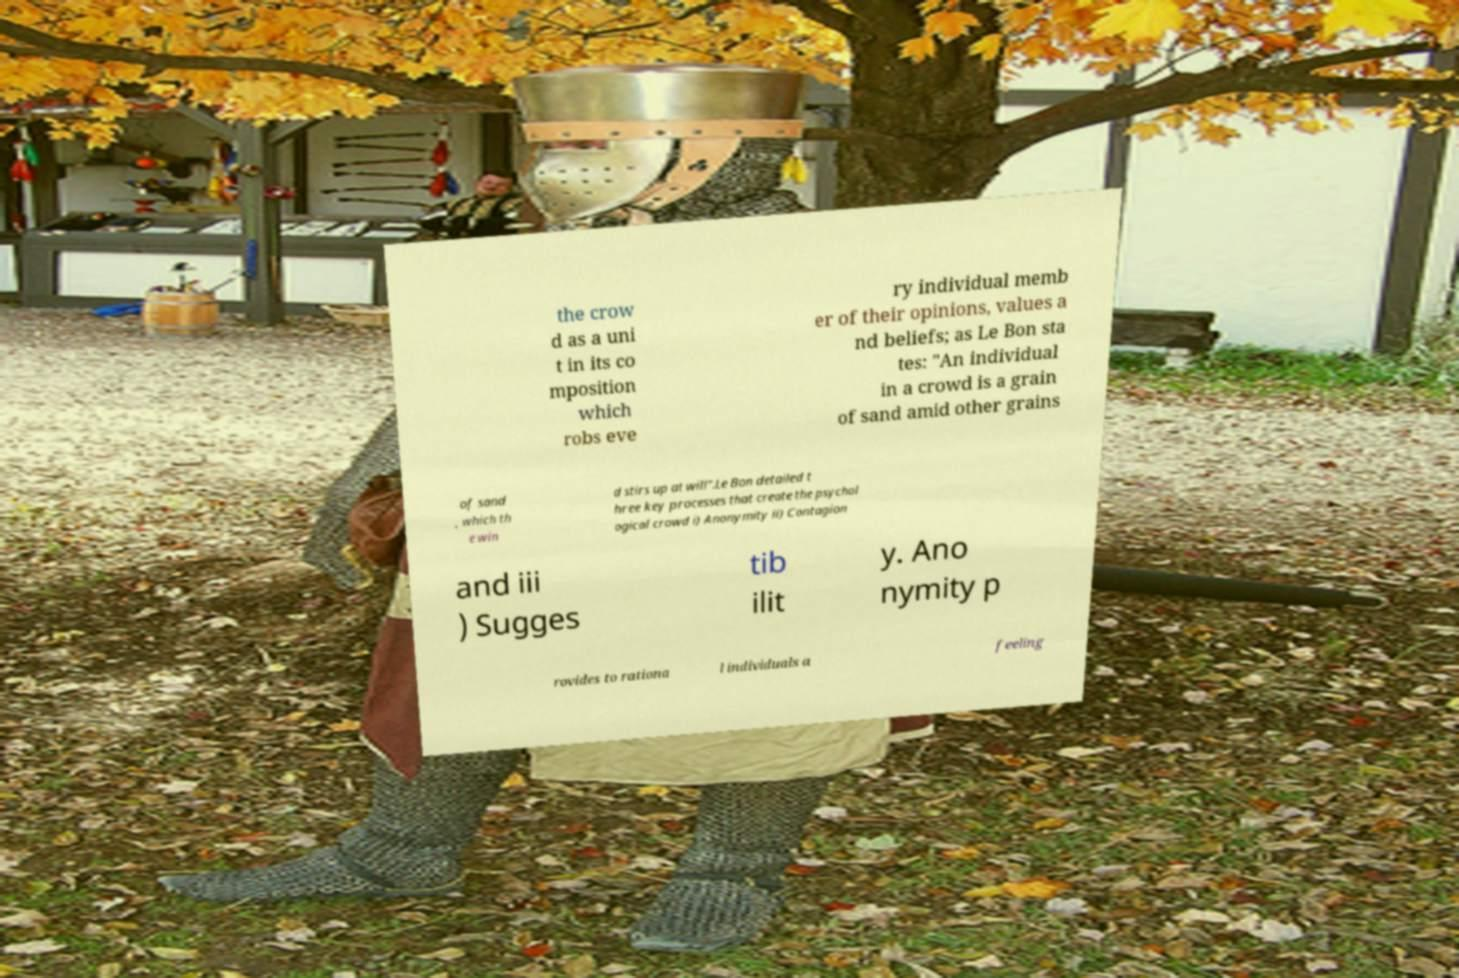Could you assist in decoding the text presented in this image and type it out clearly? the crow d as a uni t in its co mposition which robs eve ry individual memb er of their opinions, values a nd beliefs; as Le Bon sta tes: "An individual in a crowd is a grain of sand amid other grains of sand , which th e win d stirs up at will".Le Bon detailed t hree key processes that create the psychol ogical crowd i) Anonymity ii) Contagion and iii ) Sugges tib ilit y. Ano nymity p rovides to rationa l individuals a feeling 